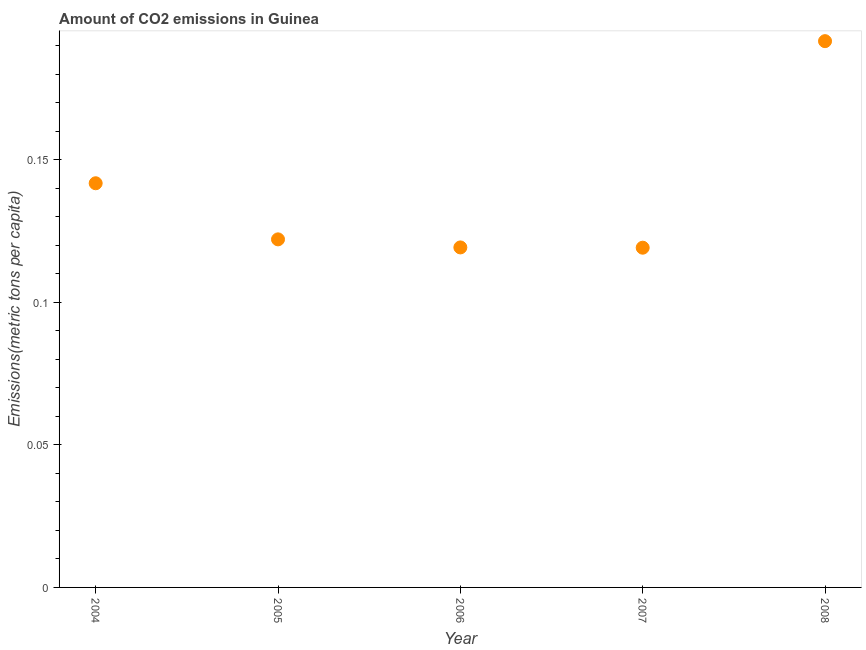What is the amount of co2 emissions in 2005?
Your answer should be compact. 0.12. Across all years, what is the maximum amount of co2 emissions?
Provide a short and direct response. 0.19. Across all years, what is the minimum amount of co2 emissions?
Offer a terse response. 0.12. In which year was the amount of co2 emissions maximum?
Offer a very short reply. 2008. In which year was the amount of co2 emissions minimum?
Your response must be concise. 2007. What is the sum of the amount of co2 emissions?
Give a very brief answer. 0.69. What is the difference between the amount of co2 emissions in 2005 and 2007?
Provide a short and direct response. 0. What is the average amount of co2 emissions per year?
Your answer should be very brief. 0.14. What is the median amount of co2 emissions?
Ensure brevity in your answer.  0.12. Do a majority of the years between 2005 and 2004 (inclusive) have amount of co2 emissions greater than 0.04 metric tons per capita?
Your response must be concise. No. What is the ratio of the amount of co2 emissions in 2004 to that in 2007?
Keep it short and to the point. 1.19. What is the difference between the highest and the second highest amount of co2 emissions?
Your response must be concise. 0.05. Is the sum of the amount of co2 emissions in 2005 and 2006 greater than the maximum amount of co2 emissions across all years?
Give a very brief answer. Yes. What is the difference between the highest and the lowest amount of co2 emissions?
Make the answer very short. 0.07. In how many years, is the amount of co2 emissions greater than the average amount of co2 emissions taken over all years?
Provide a succinct answer. 2. Does the amount of co2 emissions monotonically increase over the years?
Provide a succinct answer. No. What is the difference between two consecutive major ticks on the Y-axis?
Ensure brevity in your answer.  0.05. What is the title of the graph?
Your response must be concise. Amount of CO2 emissions in Guinea. What is the label or title of the X-axis?
Give a very brief answer. Year. What is the label or title of the Y-axis?
Ensure brevity in your answer.  Emissions(metric tons per capita). What is the Emissions(metric tons per capita) in 2004?
Your answer should be compact. 0.14. What is the Emissions(metric tons per capita) in 2005?
Make the answer very short. 0.12. What is the Emissions(metric tons per capita) in 2006?
Give a very brief answer. 0.12. What is the Emissions(metric tons per capita) in 2007?
Give a very brief answer. 0.12. What is the Emissions(metric tons per capita) in 2008?
Your response must be concise. 0.19. What is the difference between the Emissions(metric tons per capita) in 2004 and 2005?
Your answer should be compact. 0.02. What is the difference between the Emissions(metric tons per capita) in 2004 and 2006?
Offer a very short reply. 0.02. What is the difference between the Emissions(metric tons per capita) in 2004 and 2007?
Keep it short and to the point. 0.02. What is the difference between the Emissions(metric tons per capita) in 2004 and 2008?
Ensure brevity in your answer.  -0.05. What is the difference between the Emissions(metric tons per capita) in 2005 and 2006?
Make the answer very short. 0. What is the difference between the Emissions(metric tons per capita) in 2005 and 2007?
Your response must be concise. 0. What is the difference between the Emissions(metric tons per capita) in 2005 and 2008?
Offer a very short reply. -0.07. What is the difference between the Emissions(metric tons per capita) in 2006 and 2007?
Your response must be concise. 0. What is the difference between the Emissions(metric tons per capita) in 2006 and 2008?
Make the answer very short. -0.07. What is the difference between the Emissions(metric tons per capita) in 2007 and 2008?
Offer a terse response. -0.07. What is the ratio of the Emissions(metric tons per capita) in 2004 to that in 2005?
Provide a short and direct response. 1.16. What is the ratio of the Emissions(metric tons per capita) in 2004 to that in 2006?
Provide a short and direct response. 1.19. What is the ratio of the Emissions(metric tons per capita) in 2004 to that in 2007?
Ensure brevity in your answer.  1.19. What is the ratio of the Emissions(metric tons per capita) in 2004 to that in 2008?
Keep it short and to the point. 0.74. What is the ratio of the Emissions(metric tons per capita) in 2005 to that in 2006?
Provide a succinct answer. 1.02. What is the ratio of the Emissions(metric tons per capita) in 2005 to that in 2007?
Keep it short and to the point. 1.02. What is the ratio of the Emissions(metric tons per capita) in 2005 to that in 2008?
Provide a short and direct response. 0.64. What is the ratio of the Emissions(metric tons per capita) in 2006 to that in 2007?
Your answer should be compact. 1. What is the ratio of the Emissions(metric tons per capita) in 2006 to that in 2008?
Your answer should be compact. 0.62. What is the ratio of the Emissions(metric tons per capita) in 2007 to that in 2008?
Your response must be concise. 0.62. 